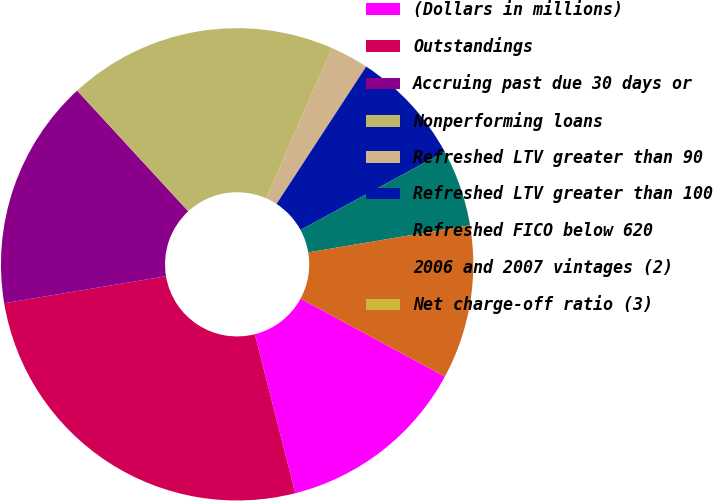<chart> <loc_0><loc_0><loc_500><loc_500><pie_chart><fcel>(Dollars in millions)<fcel>Outstandings<fcel>Accruing past due 30 days or<fcel>Nonperforming loans<fcel>Refreshed LTV greater than 90<fcel>Refreshed LTV greater than 100<fcel>Refreshed FICO below 620<fcel>2006 and 2007 vintages (2)<fcel>Net charge-off ratio (3)<nl><fcel>13.16%<fcel>26.32%<fcel>15.79%<fcel>18.42%<fcel>2.63%<fcel>7.89%<fcel>5.26%<fcel>10.53%<fcel>0.0%<nl></chart> 